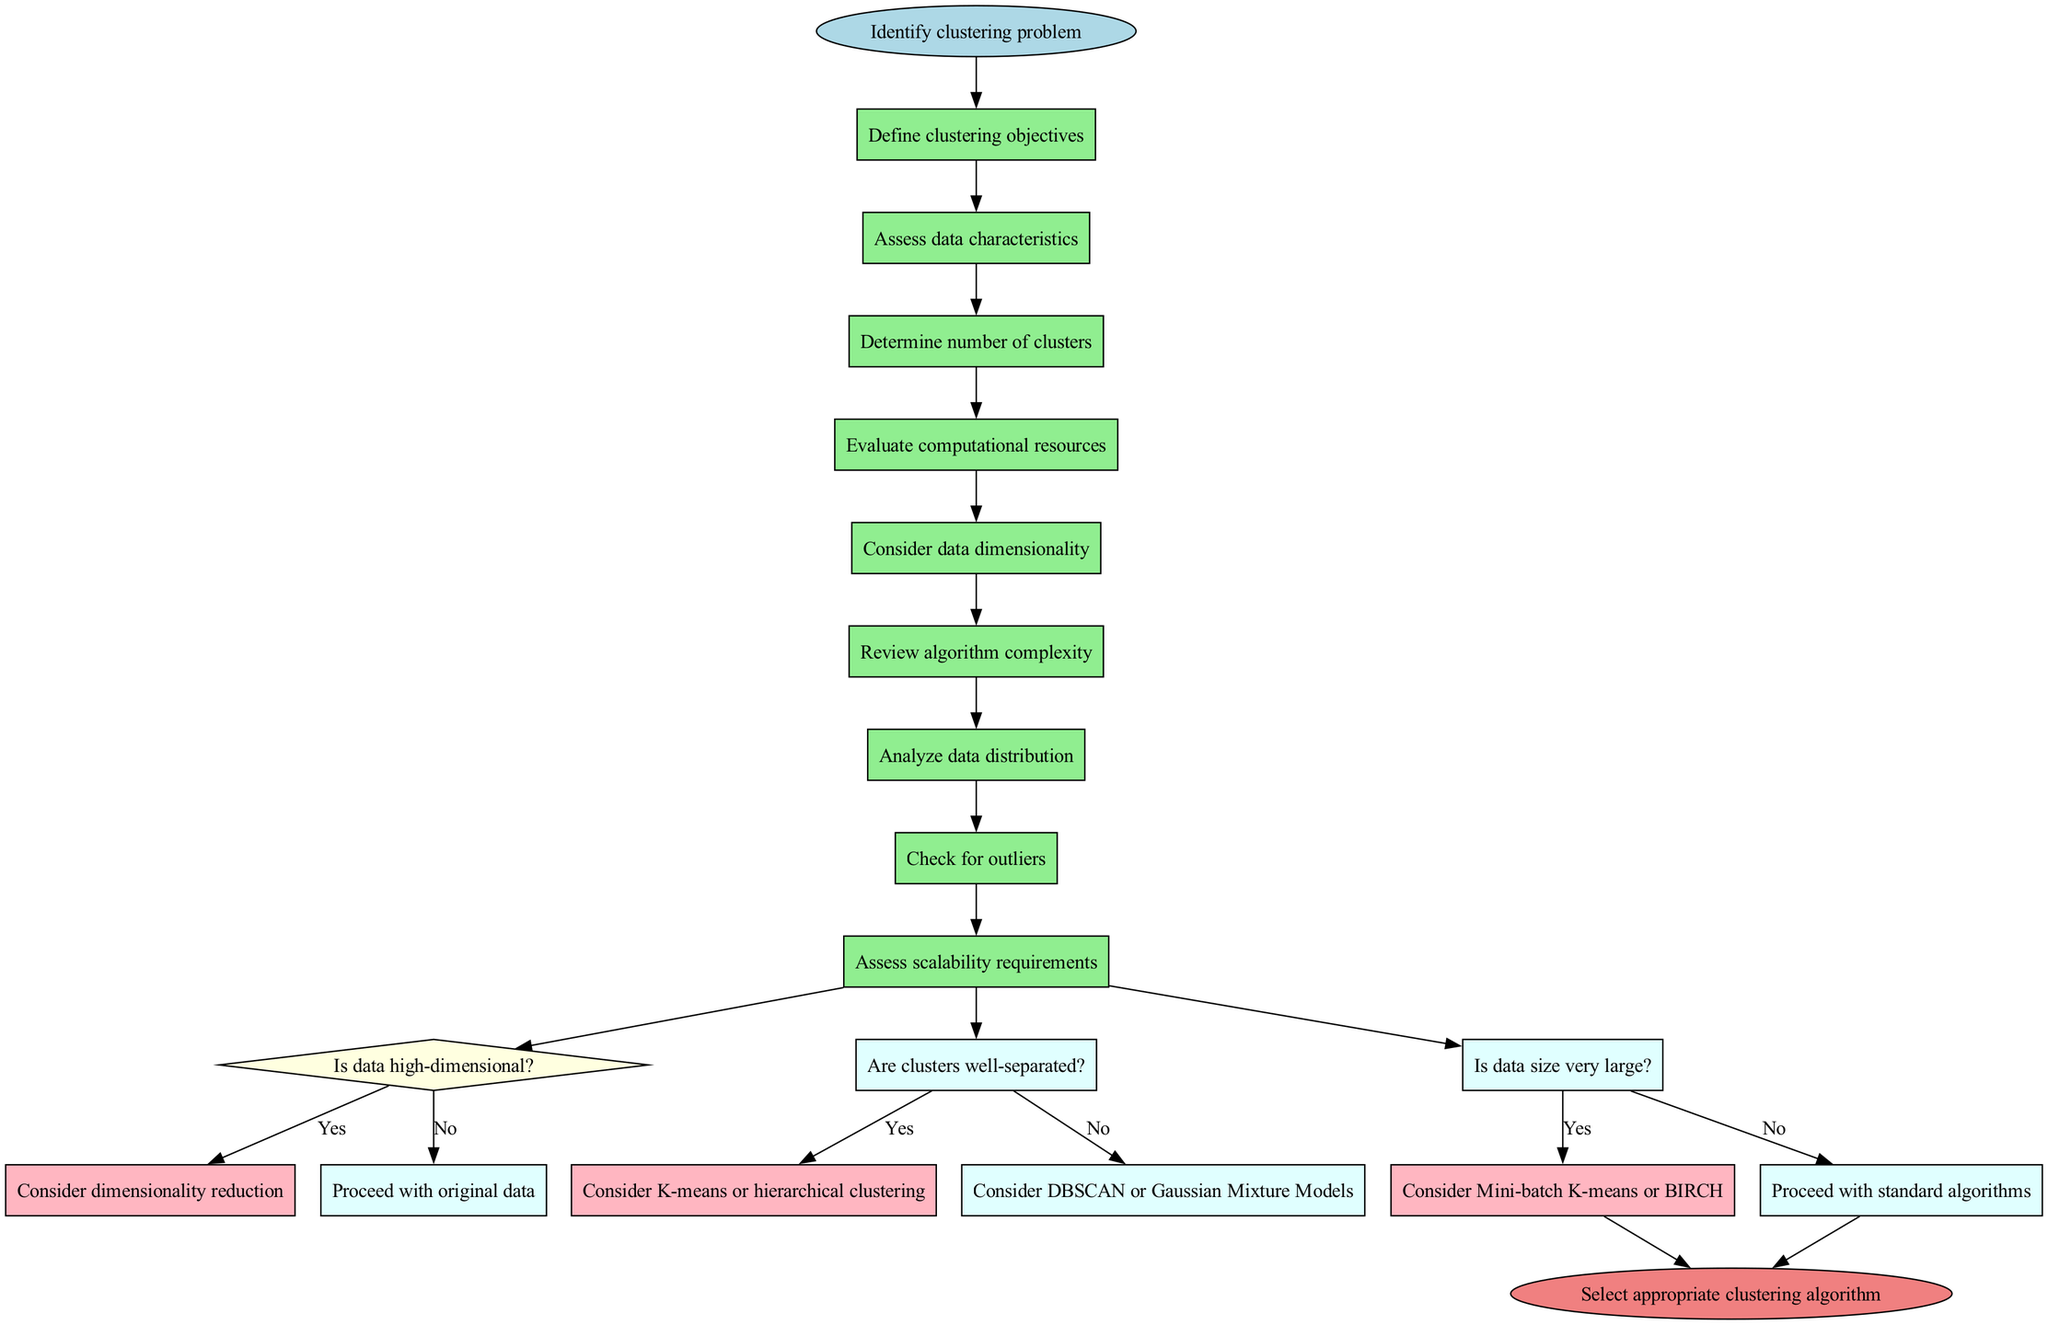What is the starting point of the diagram? The starting point is labeled as "Identify clustering problem," which indicates where the process begins in the diagram.
Answer: Identify clustering problem How many activities are listed in the diagram? There are 8 activities listed, which can be counted by reviewing the activities section of the diagram.
Answer: 8 What decision follows the "Assess data characteristics" activity? The decision that follows this activity is "Is data high-dimensional?" This can be derived from tracing the flow from the previous activity to the decision node.
Answer: Is data high-dimensional? What is the outcome if the answer to "Is data size very large?" is "Yes"? If the answer is "Yes," the outcome is to "Consider Mini-batch K-means or BIRCH," which can be found by following the decision branch for "Yes" linked to this question.
Answer: Consider Mini-batch K-means or BIRCH What color are the decision nodes in the diagram? The decision nodes are colored light yellow, which can be identified by reviewing the color coding applied to the decision shapes in the diagram.
Answer: Light yellow Which activity comes before "Check for outliers"? The activity that comes before "Check for outliers" is "Analyze data distribution," obtained by looking at the sequence of the activities in the flow before that particular node.
Answer: Analyze data distribution What happens if the answer to "Are clusters well-separated?" is "No"? If "No," then the next step is "Consider DBSCAN or Gaussian Mixture Models," as shown in the decision path for that response.
Answer: Consider DBSCAN or Gaussian Mixture Models What is the end point of the decision-making process? The end point is indicated as "Select appropriate clustering algorithm," which is the conclusion of the workflow in the diagram.
Answer: Select appropriate clustering algorithm 